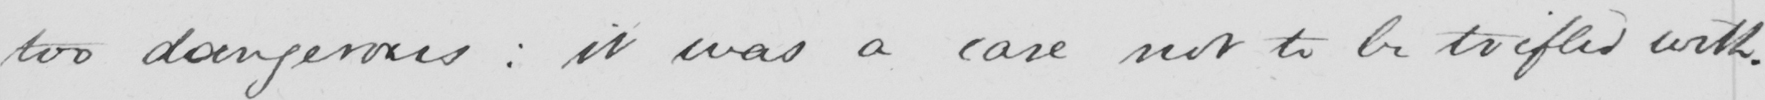Can you read and transcribe this handwriting? too dangerous :  it was a case not to be trifled with . 